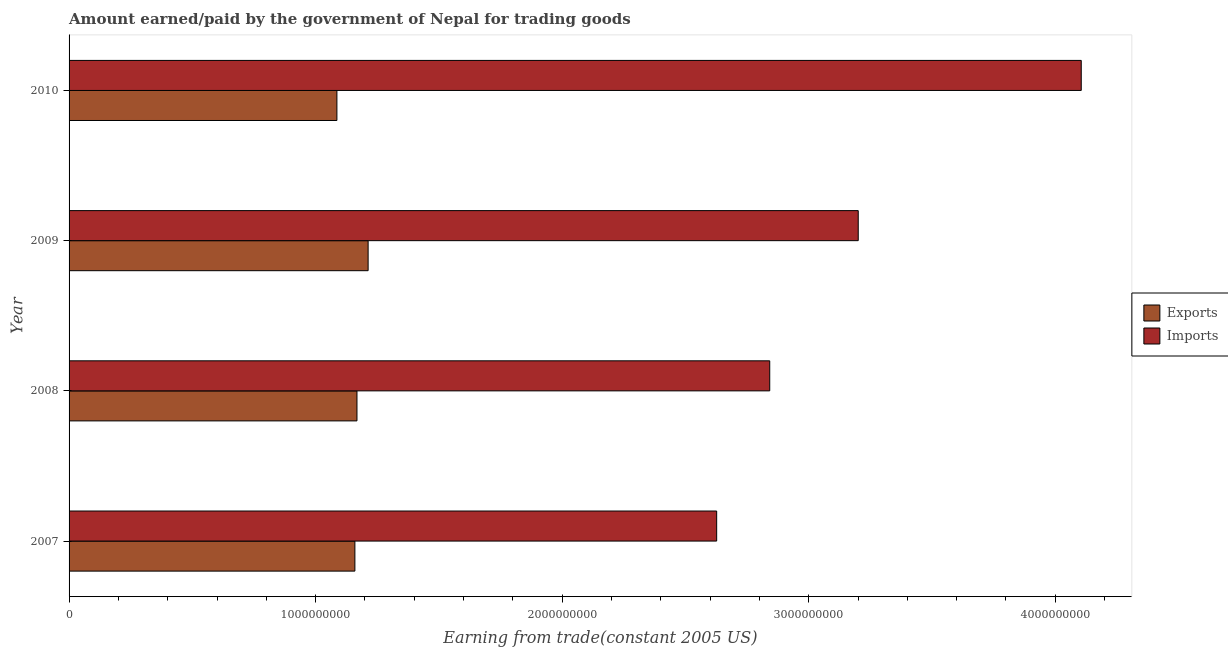Are the number of bars on each tick of the Y-axis equal?
Give a very brief answer. Yes. How many bars are there on the 3rd tick from the bottom?
Your response must be concise. 2. What is the amount earned from exports in 2008?
Offer a very short reply. 1.17e+09. Across all years, what is the maximum amount earned from exports?
Keep it short and to the point. 1.21e+09. Across all years, what is the minimum amount earned from exports?
Your answer should be very brief. 1.09e+09. In which year was the amount earned from exports maximum?
Your response must be concise. 2009. In which year was the amount paid for imports minimum?
Provide a short and direct response. 2007. What is the total amount paid for imports in the graph?
Offer a very short reply. 1.28e+1. What is the difference between the amount earned from exports in 2007 and that in 2008?
Offer a very short reply. -8.43e+06. What is the difference between the amount paid for imports in 2009 and the amount earned from exports in 2007?
Ensure brevity in your answer.  2.04e+09. What is the average amount paid for imports per year?
Your answer should be compact. 3.19e+09. In the year 2010, what is the difference between the amount earned from exports and amount paid for imports?
Your answer should be very brief. -3.02e+09. What is the ratio of the amount earned from exports in 2007 to that in 2009?
Ensure brevity in your answer.  0.96. Is the amount paid for imports in 2008 less than that in 2010?
Offer a very short reply. Yes. What is the difference between the highest and the second highest amount earned from exports?
Your response must be concise. 4.52e+07. What is the difference between the highest and the lowest amount paid for imports?
Your answer should be compact. 1.48e+09. In how many years, is the amount paid for imports greater than the average amount paid for imports taken over all years?
Give a very brief answer. 2. What does the 2nd bar from the top in 2007 represents?
Provide a succinct answer. Exports. What does the 2nd bar from the bottom in 2009 represents?
Offer a terse response. Imports. Are all the bars in the graph horizontal?
Give a very brief answer. Yes. How many years are there in the graph?
Your answer should be compact. 4. What is the difference between two consecutive major ticks on the X-axis?
Your answer should be compact. 1.00e+09. Are the values on the major ticks of X-axis written in scientific E-notation?
Give a very brief answer. No. Does the graph contain any zero values?
Provide a succinct answer. No. Does the graph contain grids?
Give a very brief answer. No. How many legend labels are there?
Your response must be concise. 2. How are the legend labels stacked?
Give a very brief answer. Vertical. What is the title of the graph?
Ensure brevity in your answer.  Amount earned/paid by the government of Nepal for trading goods. What is the label or title of the X-axis?
Offer a very short reply. Earning from trade(constant 2005 US). What is the label or title of the Y-axis?
Make the answer very short. Year. What is the Earning from trade(constant 2005 US) of Exports in 2007?
Your answer should be compact. 1.16e+09. What is the Earning from trade(constant 2005 US) in Imports in 2007?
Provide a short and direct response. 2.63e+09. What is the Earning from trade(constant 2005 US) of Exports in 2008?
Your answer should be compact. 1.17e+09. What is the Earning from trade(constant 2005 US) in Imports in 2008?
Offer a very short reply. 2.84e+09. What is the Earning from trade(constant 2005 US) of Exports in 2009?
Your response must be concise. 1.21e+09. What is the Earning from trade(constant 2005 US) of Imports in 2009?
Your answer should be very brief. 3.20e+09. What is the Earning from trade(constant 2005 US) in Exports in 2010?
Your answer should be very brief. 1.09e+09. What is the Earning from trade(constant 2005 US) of Imports in 2010?
Ensure brevity in your answer.  4.11e+09. Across all years, what is the maximum Earning from trade(constant 2005 US) in Exports?
Provide a short and direct response. 1.21e+09. Across all years, what is the maximum Earning from trade(constant 2005 US) in Imports?
Give a very brief answer. 4.11e+09. Across all years, what is the minimum Earning from trade(constant 2005 US) in Exports?
Your answer should be compact. 1.09e+09. Across all years, what is the minimum Earning from trade(constant 2005 US) in Imports?
Make the answer very short. 2.63e+09. What is the total Earning from trade(constant 2005 US) of Exports in the graph?
Ensure brevity in your answer.  4.63e+09. What is the total Earning from trade(constant 2005 US) of Imports in the graph?
Your response must be concise. 1.28e+1. What is the difference between the Earning from trade(constant 2005 US) in Exports in 2007 and that in 2008?
Give a very brief answer. -8.43e+06. What is the difference between the Earning from trade(constant 2005 US) in Imports in 2007 and that in 2008?
Give a very brief answer. -2.15e+08. What is the difference between the Earning from trade(constant 2005 US) of Exports in 2007 and that in 2009?
Offer a terse response. -5.36e+07. What is the difference between the Earning from trade(constant 2005 US) in Imports in 2007 and that in 2009?
Your response must be concise. -5.74e+08. What is the difference between the Earning from trade(constant 2005 US) of Exports in 2007 and that in 2010?
Ensure brevity in your answer.  7.30e+07. What is the difference between the Earning from trade(constant 2005 US) of Imports in 2007 and that in 2010?
Make the answer very short. -1.48e+09. What is the difference between the Earning from trade(constant 2005 US) in Exports in 2008 and that in 2009?
Your answer should be very brief. -4.52e+07. What is the difference between the Earning from trade(constant 2005 US) of Imports in 2008 and that in 2009?
Offer a very short reply. -3.59e+08. What is the difference between the Earning from trade(constant 2005 US) in Exports in 2008 and that in 2010?
Offer a terse response. 8.14e+07. What is the difference between the Earning from trade(constant 2005 US) in Imports in 2008 and that in 2010?
Offer a terse response. -1.26e+09. What is the difference between the Earning from trade(constant 2005 US) in Exports in 2009 and that in 2010?
Provide a succinct answer. 1.27e+08. What is the difference between the Earning from trade(constant 2005 US) in Imports in 2009 and that in 2010?
Give a very brief answer. -9.04e+08. What is the difference between the Earning from trade(constant 2005 US) in Exports in 2007 and the Earning from trade(constant 2005 US) in Imports in 2008?
Make the answer very short. -1.68e+09. What is the difference between the Earning from trade(constant 2005 US) in Exports in 2007 and the Earning from trade(constant 2005 US) in Imports in 2009?
Make the answer very short. -2.04e+09. What is the difference between the Earning from trade(constant 2005 US) in Exports in 2007 and the Earning from trade(constant 2005 US) in Imports in 2010?
Provide a succinct answer. -2.95e+09. What is the difference between the Earning from trade(constant 2005 US) in Exports in 2008 and the Earning from trade(constant 2005 US) in Imports in 2009?
Your answer should be compact. -2.03e+09. What is the difference between the Earning from trade(constant 2005 US) of Exports in 2008 and the Earning from trade(constant 2005 US) of Imports in 2010?
Offer a terse response. -2.94e+09. What is the difference between the Earning from trade(constant 2005 US) of Exports in 2009 and the Earning from trade(constant 2005 US) of Imports in 2010?
Provide a succinct answer. -2.89e+09. What is the average Earning from trade(constant 2005 US) of Exports per year?
Offer a terse response. 1.16e+09. What is the average Earning from trade(constant 2005 US) of Imports per year?
Offer a terse response. 3.19e+09. In the year 2007, what is the difference between the Earning from trade(constant 2005 US) in Exports and Earning from trade(constant 2005 US) in Imports?
Your answer should be very brief. -1.47e+09. In the year 2008, what is the difference between the Earning from trade(constant 2005 US) of Exports and Earning from trade(constant 2005 US) of Imports?
Your answer should be compact. -1.67e+09. In the year 2009, what is the difference between the Earning from trade(constant 2005 US) of Exports and Earning from trade(constant 2005 US) of Imports?
Make the answer very short. -1.99e+09. In the year 2010, what is the difference between the Earning from trade(constant 2005 US) of Exports and Earning from trade(constant 2005 US) of Imports?
Offer a very short reply. -3.02e+09. What is the ratio of the Earning from trade(constant 2005 US) of Imports in 2007 to that in 2008?
Your answer should be compact. 0.92. What is the ratio of the Earning from trade(constant 2005 US) in Exports in 2007 to that in 2009?
Your response must be concise. 0.96. What is the ratio of the Earning from trade(constant 2005 US) of Imports in 2007 to that in 2009?
Offer a terse response. 0.82. What is the ratio of the Earning from trade(constant 2005 US) in Exports in 2007 to that in 2010?
Keep it short and to the point. 1.07. What is the ratio of the Earning from trade(constant 2005 US) of Imports in 2007 to that in 2010?
Make the answer very short. 0.64. What is the ratio of the Earning from trade(constant 2005 US) of Exports in 2008 to that in 2009?
Make the answer very short. 0.96. What is the ratio of the Earning from trade(constant 2005 US) of Imports in 2008 to that in 2009?
Make the answer very short. 0.89. What is the ratio of the Earning from trade(constant 2005 US) in Exports in 2008 to that in 2010?
Give a very brief answer. 1.07. What is the ratio of the Earning from trade(constant 2005 US) of Imports in 2008 to that in 2010?
Offer a very short reply. 0.69. What is the ratio of the Earning from trade(constant 2005 US) of Exports in 2009 to that in 2010?
Your answer should be compact. 1.12. What is the ratio of the Earning from trade(constant 2005 US) in Imports in 2009 to that in 2010?
Your answer should be very brief. 0.78. What is the difference between the highest and the second highest Earning from trade(constant 2005 US) in Exports?
Keep it short and to the point. 4.52e+07. What is the difference between the highest and the second highest Earning from trade(constant 2005 US) in Imports?
Your answer should be compact. 9.04e+08. What is the difference between the highest and the lowest Earning from trade(constant 2005 US) in Exports?
Provide a succinct answer. 1.27e+08. What is the difference between the highest and the lowest Earning from trade(constant 2005 US) in Imports?
Ensure brevity in your answer.  1.48e+09. 